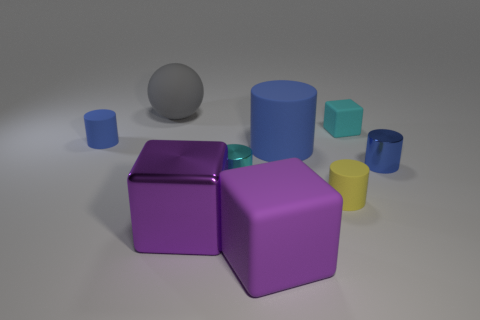Subtract all green balls. How many blue cylinders are left? 3 Subtract all cyan cylinders. How many cylinders are left? 4 Subtract all small blue shiny cylinders. How many cylinders are left? 4 Subtract all red cylinders. Subtract all blue balls. How many cylinders are left? 5 Add 1 big cyan blocks. How many objects exist? 10 Subtract all cylinders. How many objects are left? 4 Add 7 yellow matte cylinders. How many yellow matte cylinders are left? 8 Add 5 rubber cylinders. How many rubber cylinders exist? 8 Subtract 0 green cylinders. How many objects are left? 9 Subtract all tiny cyan matte blocks. Subtract all large gray rubber spheres. How many objects are left? 7 